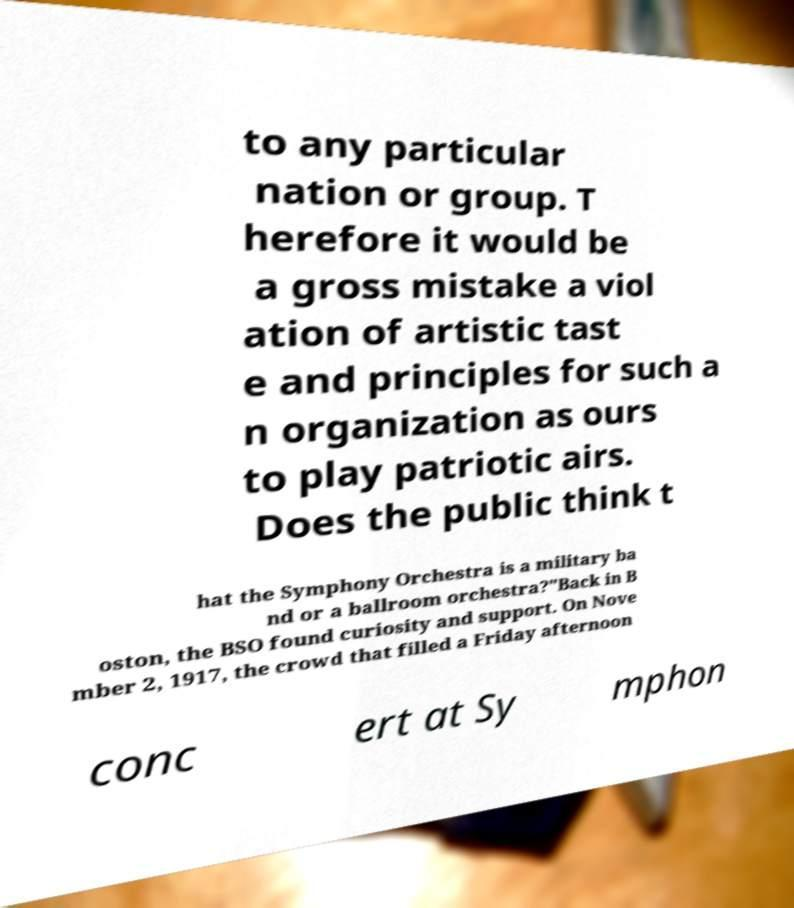I need the written content from this picture converted into text. Can you do that? to any particular nation or group. T herefore it would be a gross mistake a viol ation of artistic tast e and principles for such a n organization as ours to play patriotic airs. Does the public think t hat the Symphony Orchestra is a military ba nd or a ballroom orchestra?"Back in B oston, the BSO found curiosity and support. On Nove mber 2, 1917, the crowd that filled a Friday afternoon conc ert at Sy mphon 